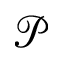Convert formula to latex. <formula><loc_0><loc_0><loc_500><loc_500>\ m a t h s c r { P }</formula> 